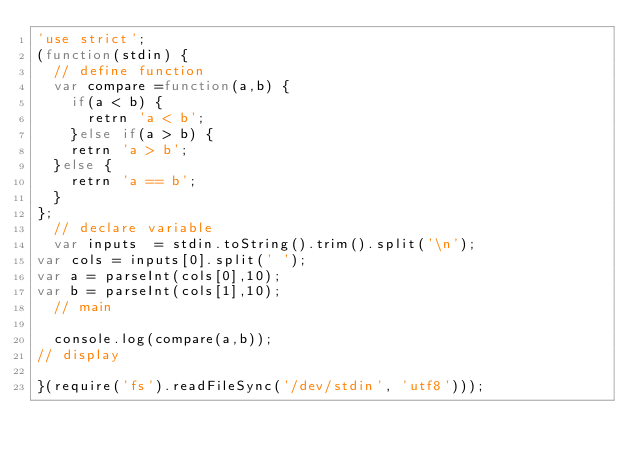<code> <loc_0><loc_0><loc_500><loc_500><_JavaScript_>'use strict';
(function(stdin) {
  // define function
  var compare =function(a,b) {
    if(a < b) {
      retrn 'a < b';
    }else if(a > b) {
    retrn 'a > b';
  }else {
    retrn 'a == b';
  }
};
  // declare variable
  var inputs  = stdin.toString().trim().split('\n'); 
var cols = inputs[0].split(' ');
var a = parseInt(cols[0],10);
var b = parseInt(cols[1],10);
  // main

  console.log(compare(a,b));
// display

}(require('fs').readFileSync('/dev/stdin', 'utf8')));</code> 